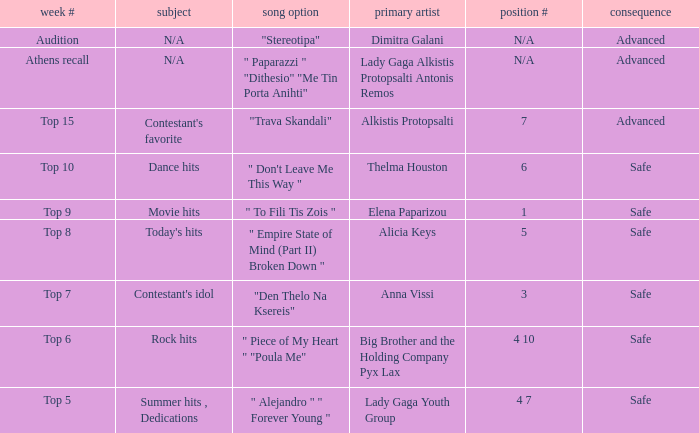Which artists have order figure 6? Thelma Houston. Could you parse the entire table? {'header': ['week #', 'subject', 'song option', 'primary artist', 'position #', 'consequence'], 'rows': [['Audition', 'N/A', '"Stereotipa"', 'Dimitra Galani', 'N/A', 'Advanced'], ['Athens recall', 'N/A', '" Paparazzi " "Dithesio" "Me Tin Porta Anihti"', 'Lady Gaga Alkistis Protopsalti Antonis Remos', 'N/A', 'Advanced'], ['Top 15', "Contestant's favorite", '"Trava Skandali"', 'Alkistis Protopsalti', '7', 'Advanced'], ['Top 10', 'Dance hits', '" Don\'t Leave Me This Way "', 'Thelma Houston', '6', 'Safe'], ['Top 9', 'Movie hits', '" To Fili Tis Zois "', 'Elena Paparizou', '1', 'Safe'], ['Top 8', "Today's hits", '" Empire State of Mind (Part II) Broken Down "', 'Alicia Keys', '5', 'Safe'], ['Top 7', "Contestant's idol", '"Den Thelo Na Ksereis"', 'Anna Vissi', '3', 'Safe'], ['Top 6', 'Rock hits', '" Piece of My Heart " "Poula Me"', 'Big Brother and the Holding Company Pyx Lax', '4 10', 'Safe'], ['Top 5', 'Summer hits , Dedications', '" Alejandro " " Forever Young "', 'Lady Gaga Youth Group', '4 7', 'Safe']]} 